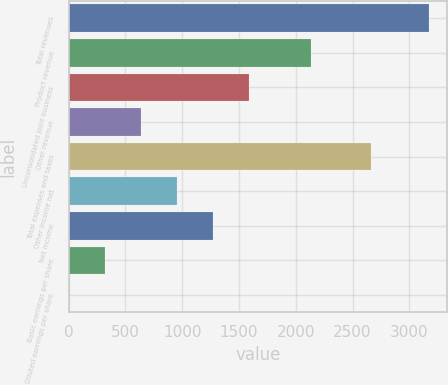<chart> <loc_0><loc_0><loc_500><loc_500><bar_chart><fcel>Total revenues<fcel>Product revenue<fcel>Unconsolidated joint business<fcel>Other revenue<fcel>Total expenses and taxes<fcel>Other income net<fcel>Net income<fcel>Basic earnings per share<fcel>Diluted earnings per share<nl><fcel>3171.6<fcel>2136.8<fcel>1586.79<fcel>635.91<fcel>2664.2<fcel>952.87<fcel>1269.83<fcel>318.95<fcel>1.99<nl></chart> 